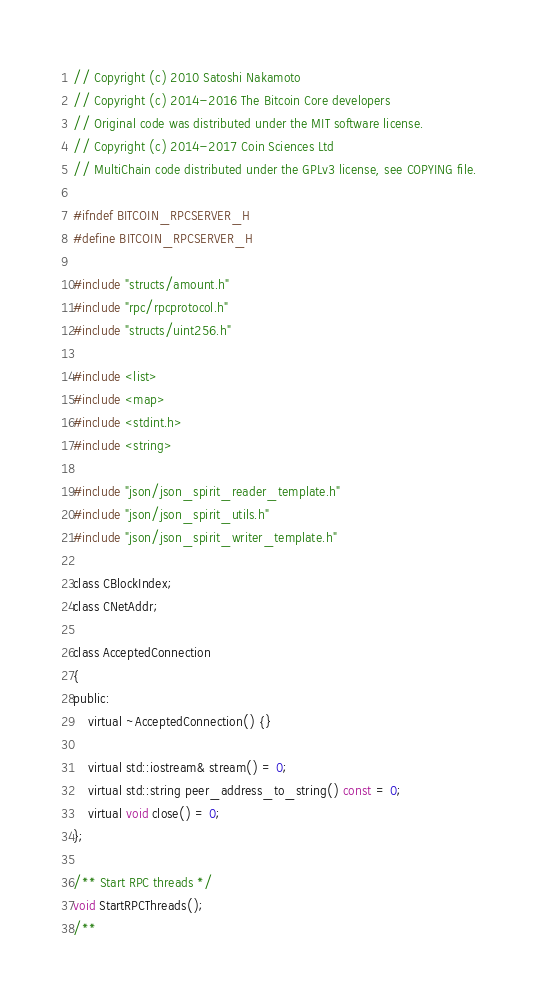<code> <loc_0><loc_0><loc_500><loc_500><_C_>// Copyright (c) 2010 Satoshi Nakamoto
// Copyright (c) 2014-2016 The Bitcoin Core developers
// Original code was distributed under the MIT software license.
// Copyright (c) 2014-2017 Coin Sciences Ltd
// MultiChain code distributed under the GPLv3 license, see COPYING file.

#ifndef BITCOIN_RPCSERVER_H
#define BITCOIN_RPCSERVER_H

#include "structs/amount.h"
#include "rpc/rpcprotocol.h"
#include "structs/uint256.h"

#include <list>
#include <map>
#include <stdint.h>
#include <string>

#include "json/json_spirit_reader_template.h"
#include "json/json_spirit_utils.h"
#include "json/json_spirit_writer_template.h"

class CBlockIndex;
class CNetAddr;

class AcceptedConnection
{
public:
    virtual ~AcceptedConnection() {}

    virtual std::iostream& stream() = 0;
    virtual std::string peer_address_to_string() const = 0;
    virtual void close() = 0;
};

/** Start RPC threads */
void StartRPCThreads();
/**</code> 